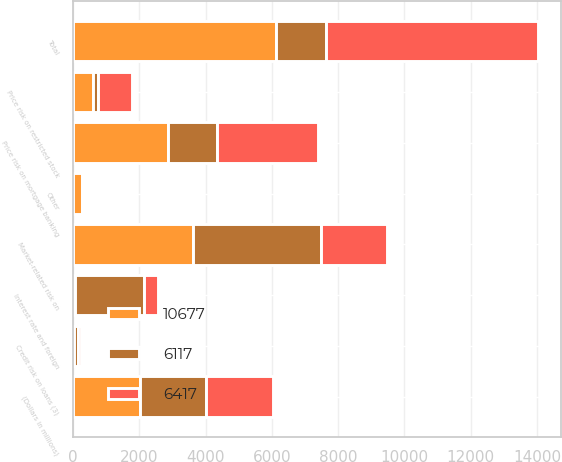Convert chart. <chart><loc_0><loc_0><loc_500><loc_500><stacked_bar_chart><ecel><fcel>(Dollars in millions)<fcel>Price risk on mortgage banking<fcel>Market-related risk on<fcel>Credit risk on loans (3)<fcel>Interest rate and foreign<fcel>Price risk on restricted stock<fcel>Other<fcel>Total<nl><fcel>6417<fcel>2012<fcel>3022<fcel>2000<fcel>95<fcel>424<fcel>1008<fcel>58<fcel>6417<nl><fcel>10677<fcel>2011<fcel>2852<fcel>3612<fcel>30<fcel>48<fcel>610<fcel>281<fcel>6117<nl><fcel>6117<fcel>2010<fcel>1504<fcel>3878<fcel>121<fcel>2080<fcel>151<fcel>42<fcel>1504<nl></chart> 